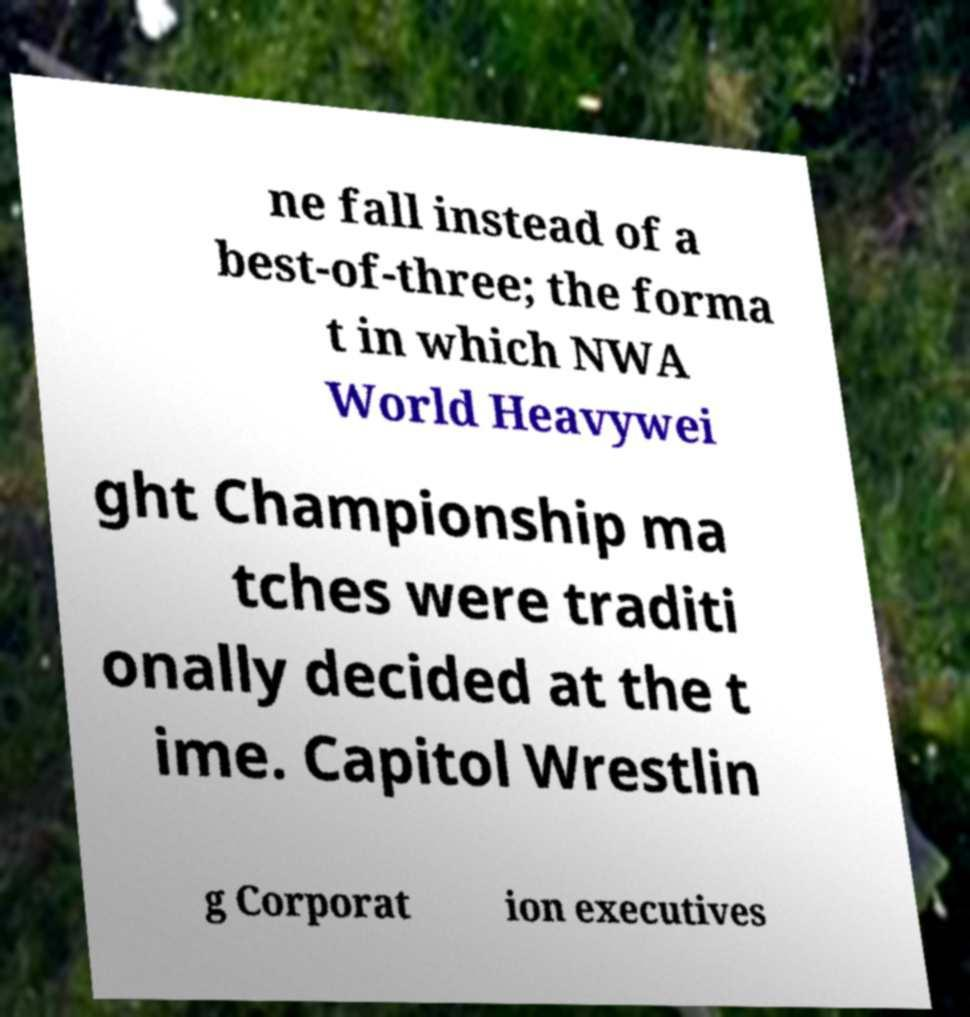Can you read and provide the text displayed in the image?This photo seems to have some interesting text. Can you extract and type it out for me? ne fall instead of a best-of-three; the forma t in which NWA World Heavywei ght Championship ma tches were traditi onally decided at the t ime. Capitol Wrestlin g Corporat ion executives 